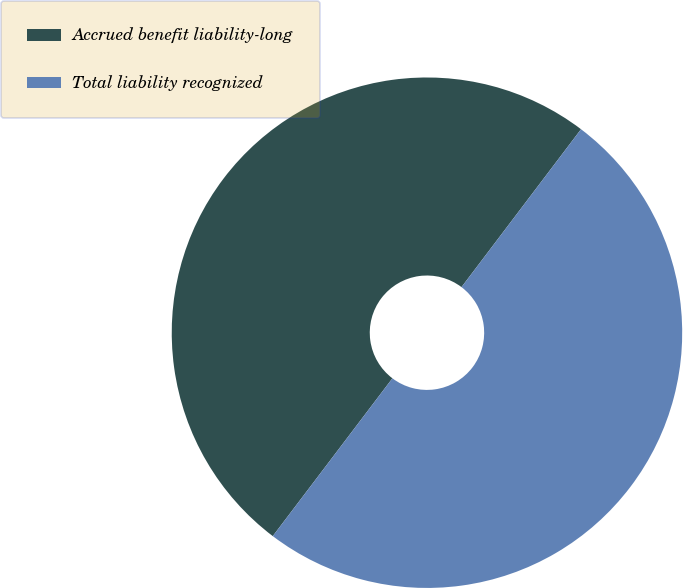Convert chart. <chart><loc_0><loc_0><loc_500><loc_500><pie_chart><fcel>Accrued benefit liability-long<fcel>Total liability recognized<nl><fcel>49.99%<fcel>50.01%<nl></chart> 